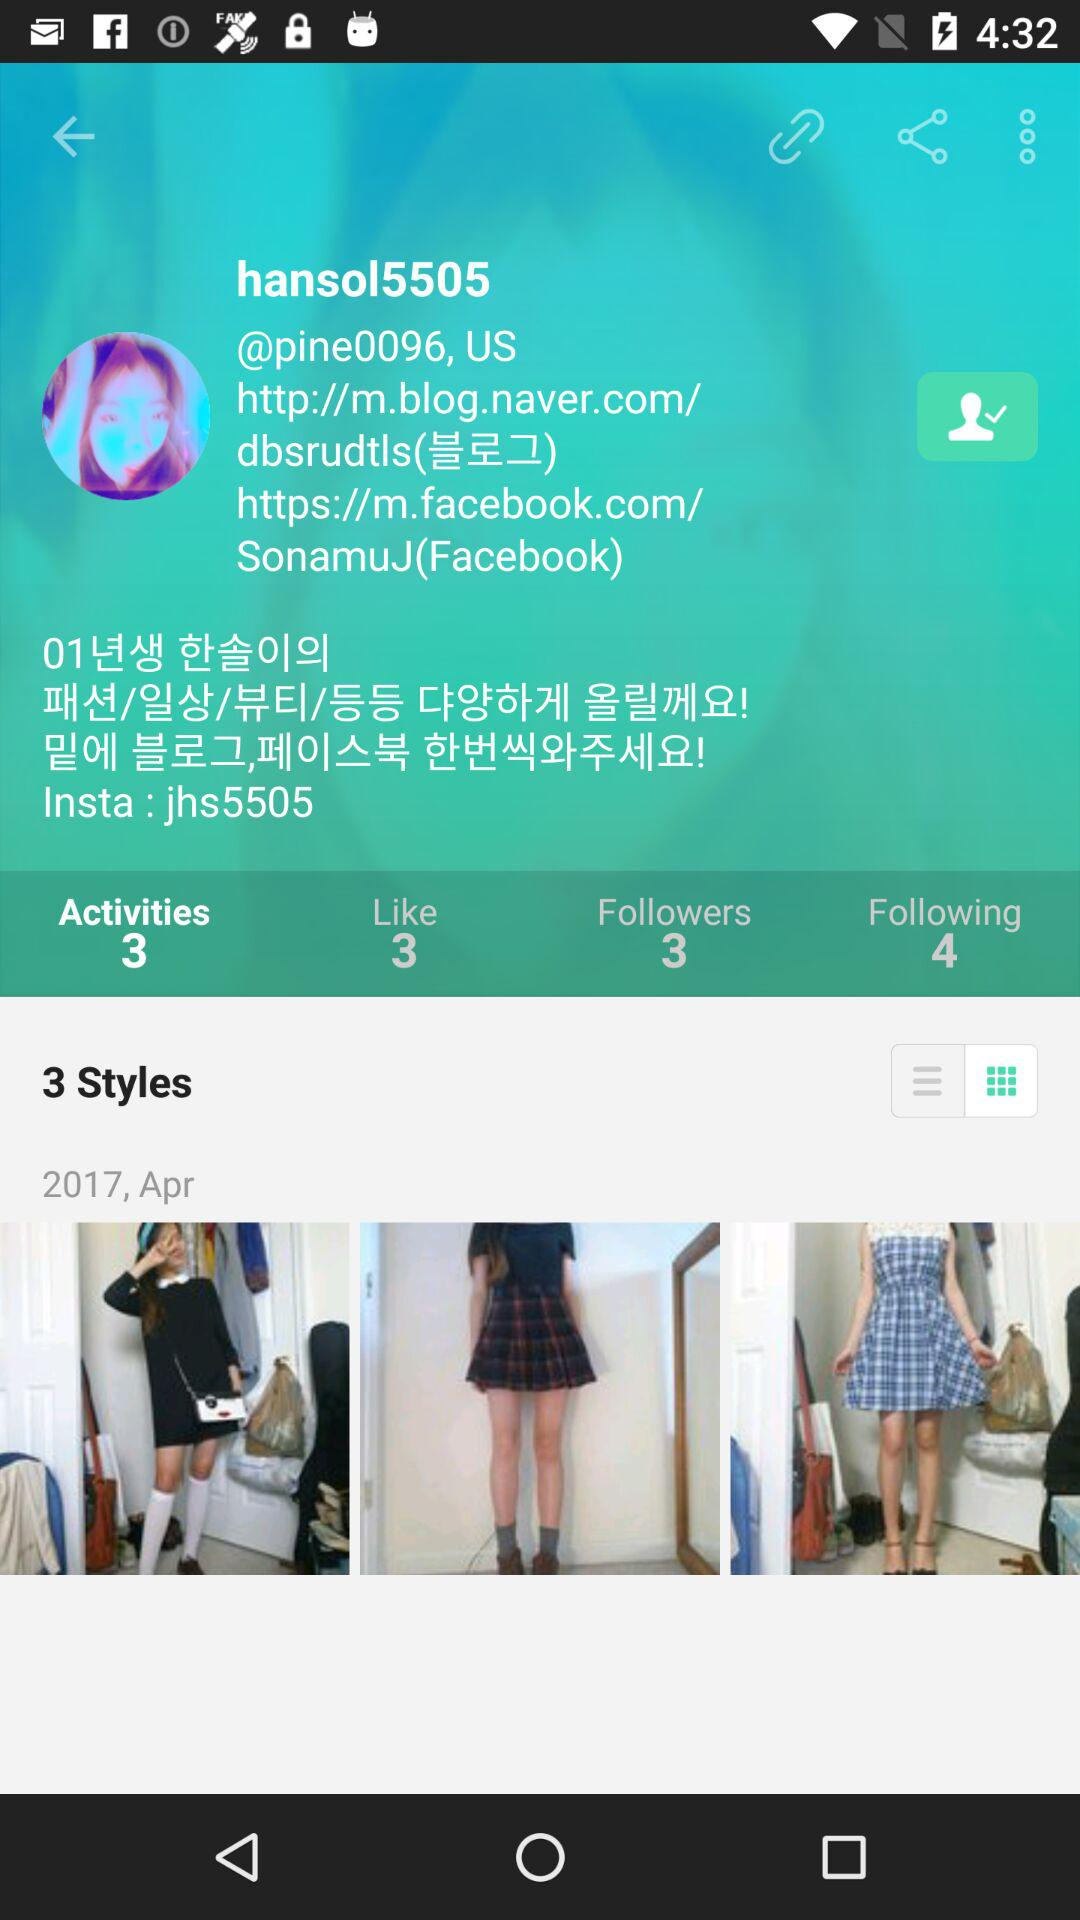What is the number of followers? The number of followers is 3. 